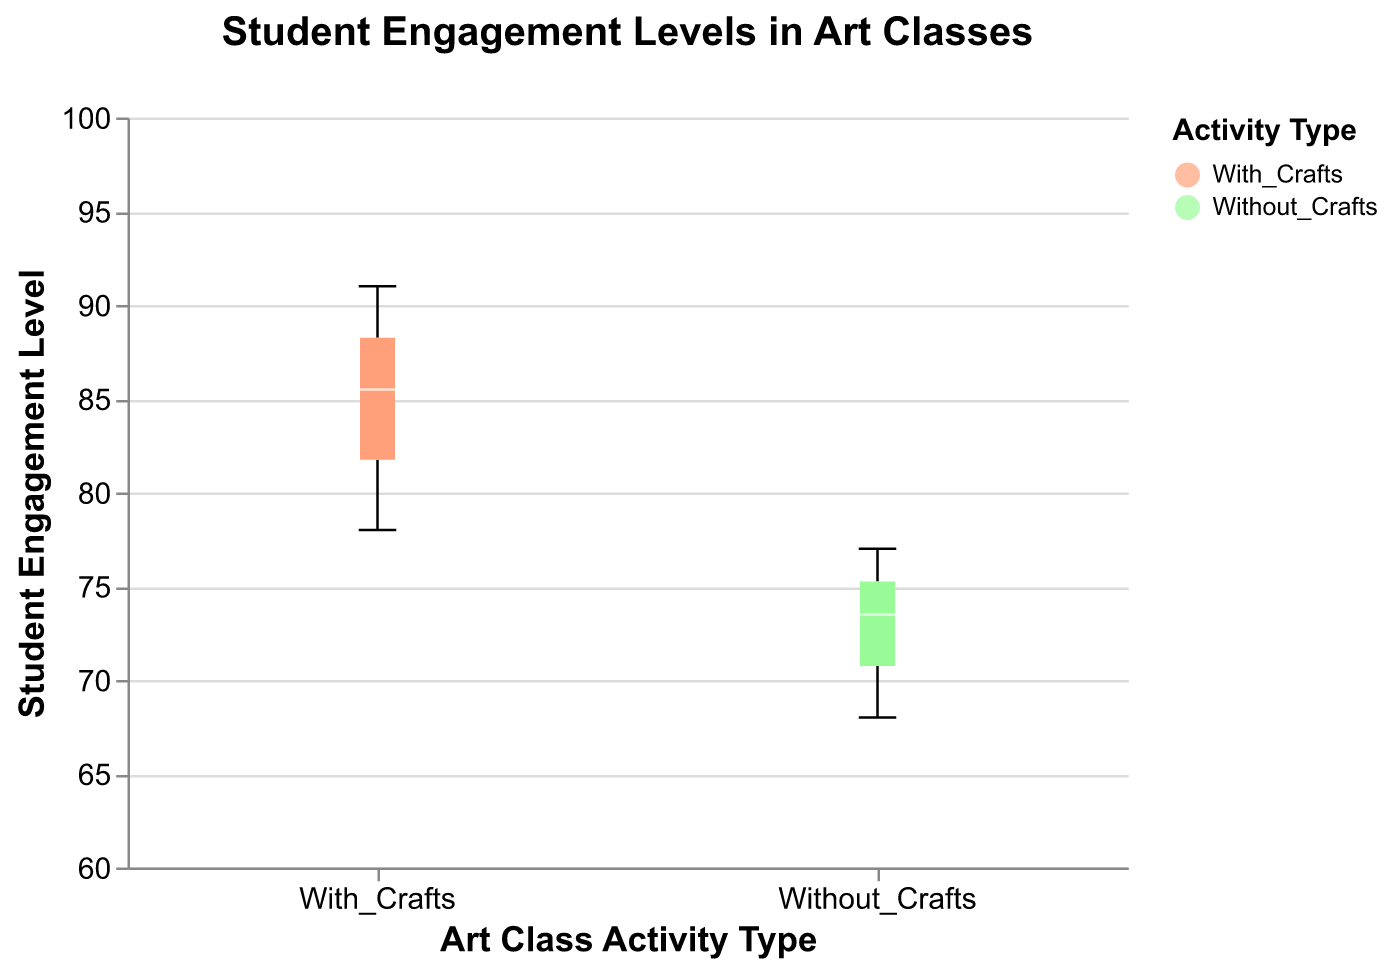What is the title of the figure? The title is located at the top center of the figure and clearly states the topic being visualized.
Answer: Student Engagement Levels in Art Classes What are the two different activity types represented in the figure? The two activity types are indicated on the x-axis and in the legend with different colors.
Answer: With_Crafts and Without_Crafts Which activity type has the highest median student engagement level? By looking at the median lines (colored white) within the box plots, we can identify the median value for each activity type.
Answer: With_Crafts What is the range of engagement levels for students with craft activities? The range of a box plot is shown by the vertical lines extending from the boxes (whiskers). The minimum and maximum points define this range.
Answer: 77 to 91 How many students were included in each activity group? Count the number of data points (students) represented by the box plot markers for each activity type by referring to the legend's colors and the respective dots within each group.
Answer: 12 in each group What is the interquartile range (IQR) for student engagement levels with craft activities? The IQR is the range between the first quartile (Q1, bottom of the box) and the third quartile (Q3, top of the box). Locate these points on the y-axis for With_Crafts.
Answer: 81 to 87 Which activity type has a higher variability in engagement levels? Variability can be assessed by the length of the box and whiskers. Compare the lengths for each activity type.
Answer: Without_Crafts Are there any outliers in the engagement levels for either activity type? Outliers are typically represented as points beyond the whiskers. Check both box plots for any such individual points.
Answer: No How does the median engagement level with crafts compare to the median engagement level without crafts? Compare the median lines (white) of each box plot vertically on the y-axis.
Answer: The median engagement level with crafts is higher than without crafts 